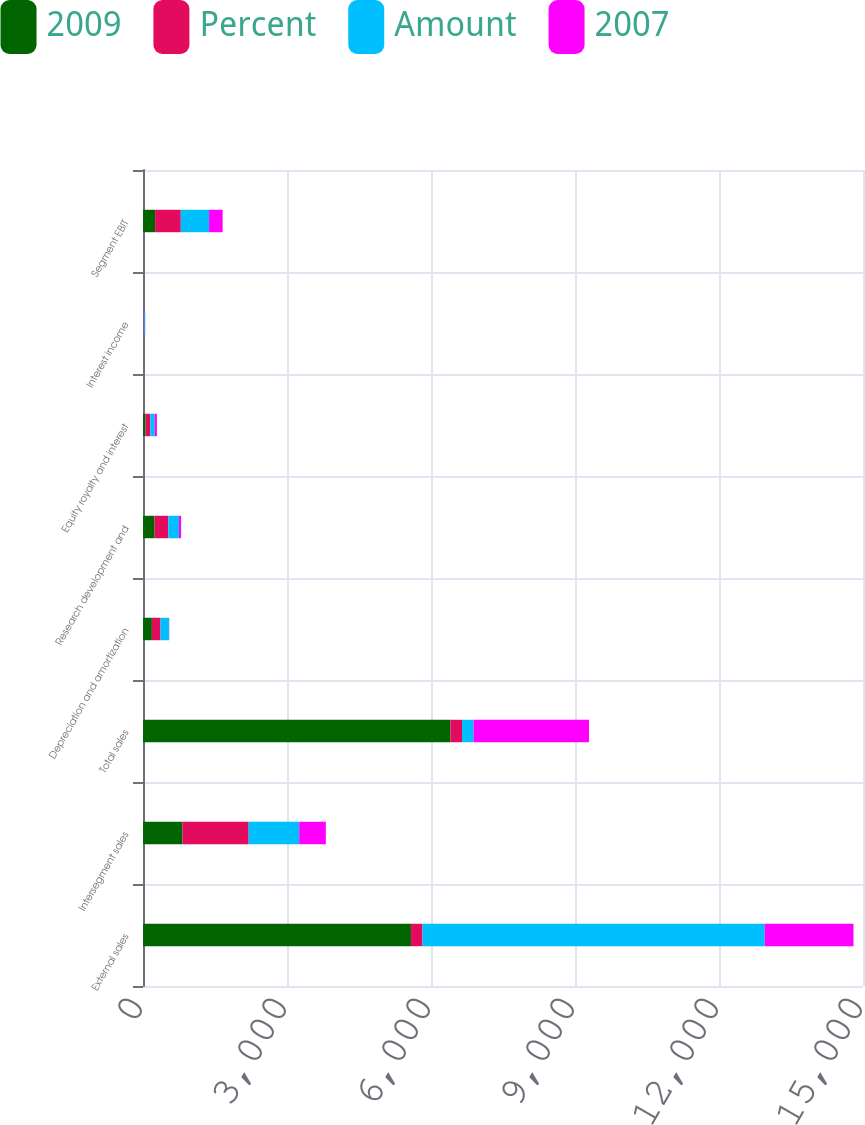Convert chart. <chart><loc_0><loc_0><loc_500><loc_500><stacked_bar_chart><ecel><fcel>External sales<fcel>Intersegment sales<fcel>Total sales<fcel>Depreciation and amortization<fcel>Research development and<fcel>Equity royalty and interest<fcel>Interest income<fcel>Segment EBIT<nl><fcel>2009<fcel>5582<fcel>823<fcel>6405<fcel>185<fcel>241<fcel>54<fcel>3<fcel>252<nl><fcel>Percent<fcel>241<fcel>1378<fcel>241<fcel>180<fcel>286<fcel>99<fcel>10<fcel>535<nl><fcel>Amount<fcel>7129<fcel>1053<fcel>241<fcel>176<fcel>222<fcel>92<fcel>26<fcel>589<nl><fcel>2007<fcel>1850<fcel>555<fcel>2405<fcel>5<fcel>45<fcel>45<fcel>7<fcel>283<nl></chart> 